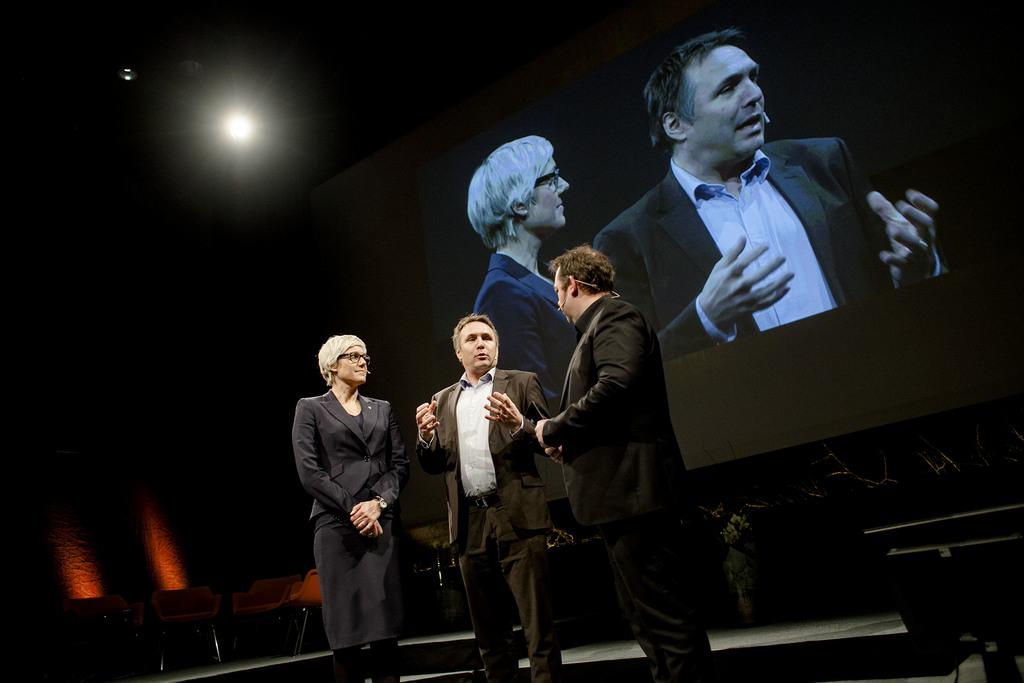How many people are present in the image? There are three people in the image. Where are the people located in the image? The people are standing on a stage. What are the people doing in the image? The people are talking. What can be seen at the back side of the image? The people's images are projected at the back side. What type of flowers can be seen growing on the dock in the image? There is no dock or flowers present in the image. Can you describe the voice of the person speaking in the image? The image is a still photograph, so there is no voice or audio present to describe. 